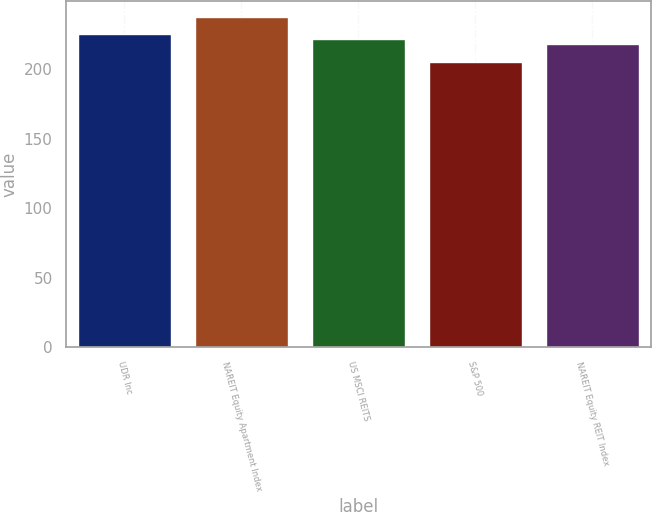Convert chart to OTSL. <chart><loc_0><loc_0><loc_500><loc_500><bar_chart><fcel>UDR Inc<fcel>NAREIT Equity Apartment Index<fcel>US MSCI REITS<fcel>S&P 500<fcel>NAREIT Equity REIT Index<nl><fcel>224.86<fcel>237.02<fcel>221.35<fcel>205.14<fcel>218.16<nl></chart> 